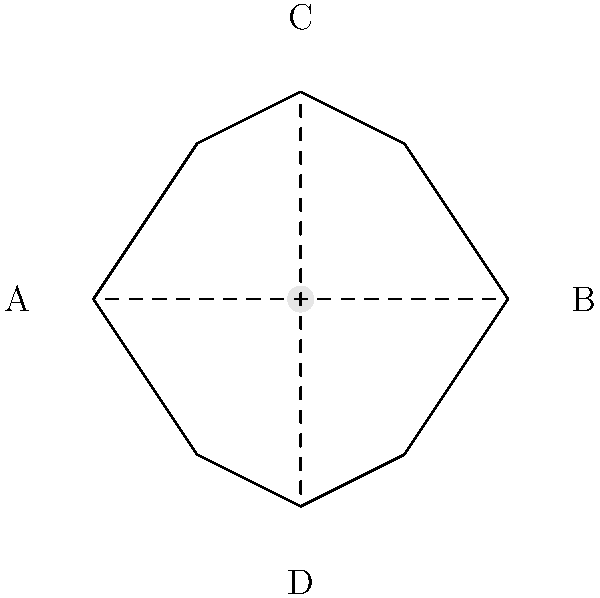In the diagram above, a simplified representation of an acoustic guitar's body is shown. The shape of the guitar body significantly influences its sound production. If we consider the length of the guitar (from point A to B) to be 20 inches and the width (from point C to D) to be 16 inches, what is the approximate ratio of the guitar's length to its width? How might this ratio affect the instrument's tonal characteristics? Let's approach this step-by-step:

1. Identify the given dimensions:
   - Length (A to B) = 20 inches
   - Width (C to D) = 16 inches

2. Calculate the ratio of length to width:
   $$ \text{Ratio} = \frac{\text{Length}}{\text{Width}} = \frac{20 \text{ inches}}{16 \text{ inches}} = \frac{5}{4} = 1.25 $$

3. Simplify the ratio to its lowest terms:
   The ratio 5:4 is already in its simplest form.

4. Interpretation of the ratio's effect on sound:
   - The ratio of 5:4 (or 1.25:1) indicates that the guitar's length is slightly greater than its width.
   - This proportion contributes to the guitar's balanced tone:
     a) The longer dimension (length) supports lower frequencies and provides richness to the bass notes.
     b) The shorter dimension (width) enhances higher frequencies, adding brightness to the overall sound.
   - The close ratio (nearly square) helps in producing a well-rounded, full-bodied tone with a good balance between bass and treble.
   - If the ratio were more extreme (e.g., 2:1), it might result in a more pronounced emphasis on either low or high frequencies.

5. The sound hole's position and size (shown in the center of the guitar body) also play crucial roles in sound projection and resonance, working in conjunction with the body's proportions.
Answer: 5:4 ratio; balances low and high frequencies for full-bodied tone 